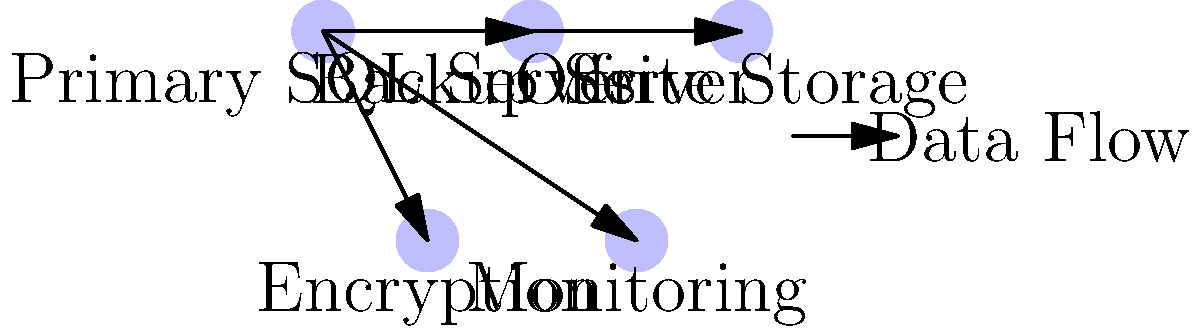Based on the diagram, which component should be implemented between the Primary SQL Server and the Backup Server to ensure data confidentiality during transmission? To answer this question, let's analyze the diagram and the secure backup and recovery process for SQL databases:

1. The diagram shows a Primary SQL Server connected to a Backup Server and an Offsite Storage.
2. There are two additional components: Encryption and Monitoring.
3. For ensuring data confidentiality during transmission between the Primary SQL Server and the Backup Server, encryption is crucial.
4. Encryption protects data from unauthorized access while it's being transferred over networks.
5. In the diagram, we can see that the Encryption component is directly connected to the Primary SQL Server.
6. This suggests that data should be encrypted before it leaves the Primary SQL Server and is sent to the Backup Server.

Therefore, to ensure data confidentiality during transmission between the Primary SQL Server and the Backup Server, the Encryption component should be implemented.
Answer: Encryption 